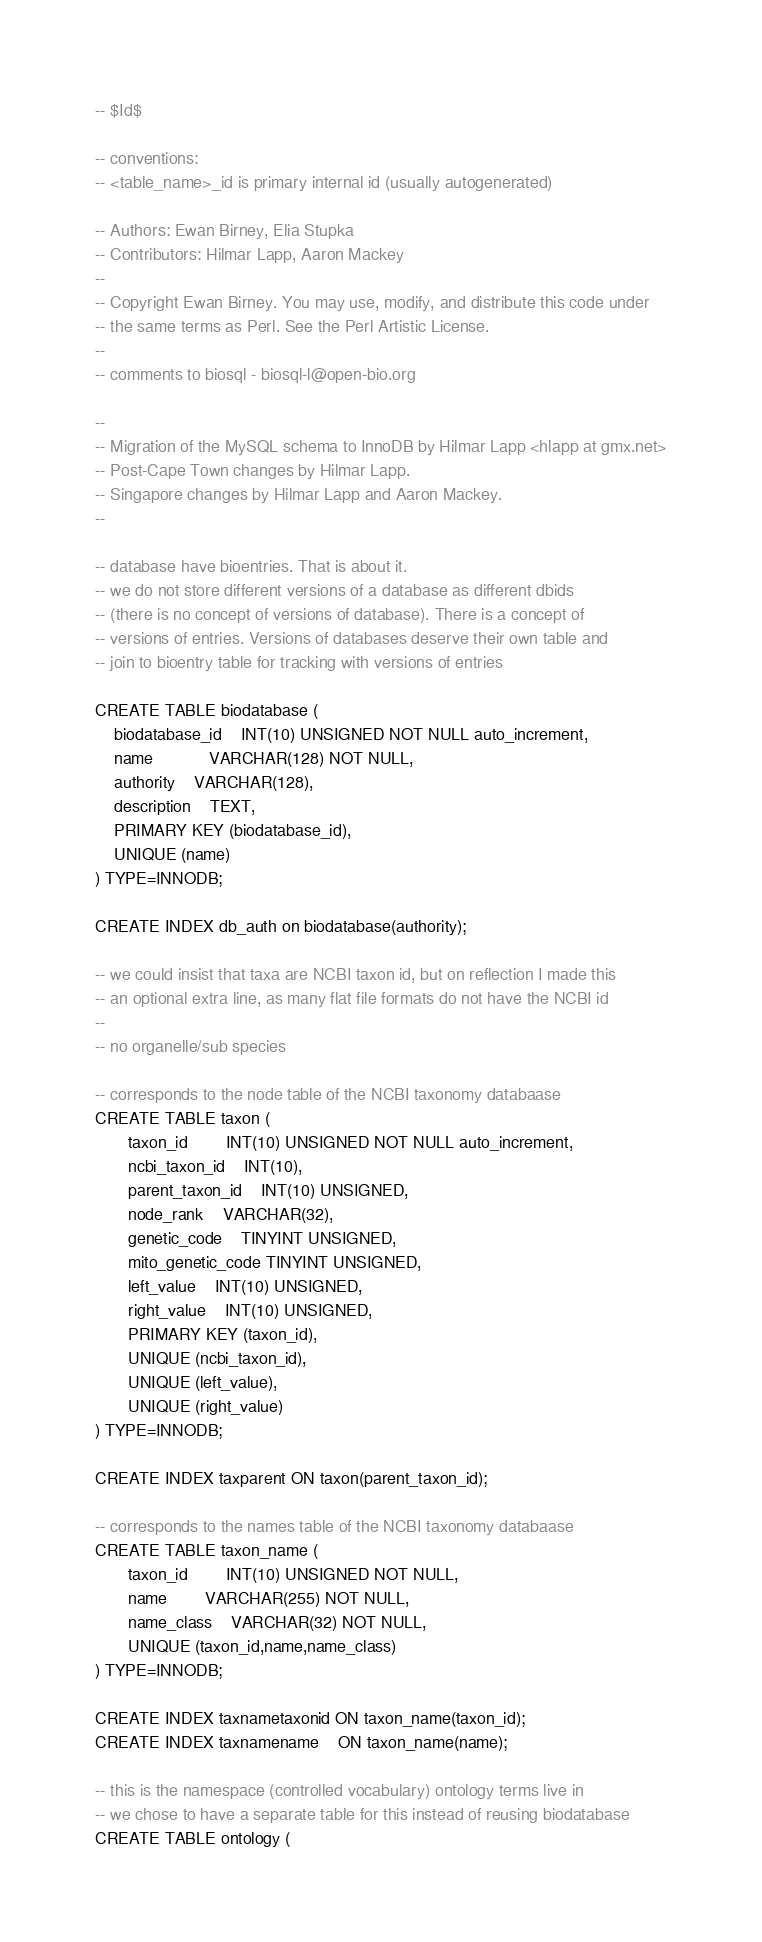<code> <loc_0><loc_0><loc_500><loc_500><_SQL_>-- $Id$

-- conventions:
-- <table_name>_id is primary internal id (usually autogenerated)

-- Authors: Ewan Birney, Elia Stupka
-- Contributors: Hilmar Lapp, Aaron Mackey
--
-- Copyright Ewan Birney. You may use, modify, and distribute this code under
-- the same terms as Perl. See the Perl Artistic License.
--
-- comments to biosql - biosql-l@open-bio.org

--
-- Migration of the MySQL schema to InnoDB by Hilmar Lapp <hlapp at gmx.net>
-- Post-Cape Town changes by Hilmar Lapp.
-- Singapore changes by Hilmar Lapp and Aaron Mackey.
--

-- database have bioentries. That is about it.
-- we do not store different versions of a database as different dbids
-- (there is no concept of versions of database). There is a concept of
-- versions of entries. Versions of databases deserve their own table and
-- join to bioentry table for tracking with versions of entries 

CREATE TABLE biodatabase (
  	biodatabase_id 	INT(10) UNSIGNED NOT NULL auto_increment,
  	name           	VARCHAR(128) NOT NULL,
	authority	VARCHAR(128),
	description	TEXT,
	PRIMARY KEY (biodatabase_id),
  	UNIQUE (name)
) TYPE=INNODB;

CREATE INDEX db_auth on biodatabase(authority);

-- we could insist that taxa are NCBI taxon id, but on reflection I made this
-- an optional extra line, as many flat file formats do not have the NCBI id
--
-- no organelle/sub species

-- corresponds to the node table of the NCBI taxonomy databaase
CREATE TABLE taxon (
       taxon_id		INT(10) UNSIGNED NOT NULL auto_increment,
       ncbi_taxon_id 	INT(10),
       parent_taxon_id	INT(10) UNSIGNED,
       node_rank	VARCHAR(32),
       genetic_code	TINYINT UNSIGNED,
       mito_genetic_code TINYINT UNSIGNED,
       left_value	INT(10) UNSIGNED,
       right_value	INT(10) UNSIGNED,
       PRIMARY KEY (taxon_id),
       UNIQUE (ncbi_taxon_id),
       UNIQUE (left_value),
       UNIQUE (right_value)
) TYPE=INNODB;

CREATE INDEX taxparent ON taxon(parent_taxon_id);

-- corresponds to the names table of the NCBI taxonomy databaase
CREATE TABLE taxon_name (
       taxon_id		INT(10) UNSIGNED NOT NULL,
       name		VARCHAR(255) NOT NULL,
       name_class	VARCHAR(32) NOT NULL,
       UNIQUE (taxon_id,name,name_class)
) TYPE=INNODB;

CREATE INDEX taxnametaxonid ON taxon_name(taxon_id);
CREATE INDEX taxnamename    ON taxon_name(name);

-- this is the namespace (controlled vocabulary) ontology terms live in
-- we chose to have a separate table for this instead of reusing biodatabase
CREATE TABLE ontology (</code> 